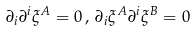<formula> <loc_0><loc_0><loc_500><loc_500>\partial _ { i } \partial ^ { i } \xi ^ { A } = 0 \, , \, \partial _ { i } \xi ^ { A } \partial ^ { i } \xi ^ { B } = 0</formula> 